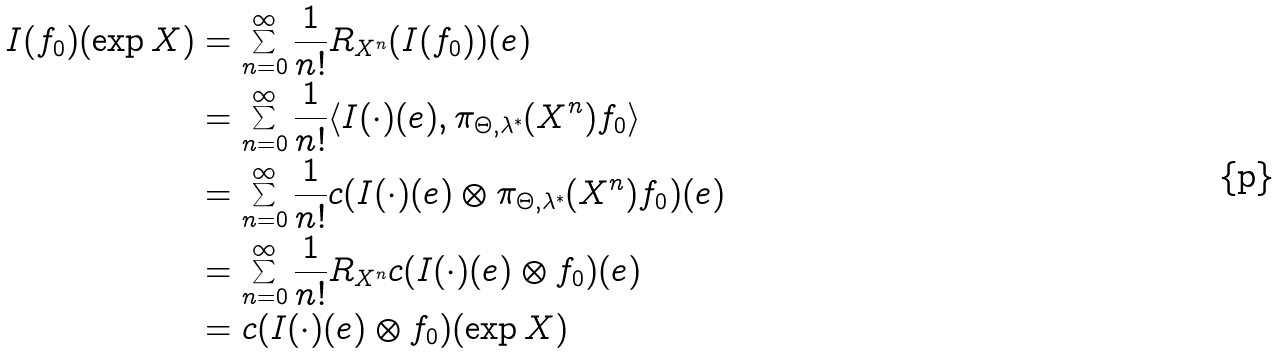<formula> <loc_0><loc_0><loc_500><loc_500>I ( f _ { 0 } ) ( \exp X ) & = \sum _ { n = 0 } ^ { \infty } \frac { 1 } { n ! } R _ { X ^ { n } } ( I ( f _ { 0 } ) ) ( e ) \\ & = \sum _ { n = 0 } ^ { \infty } \frac { 1 } { n ! } \langle I ( \cdot ) ( e ) , \pi _ { \Theta , \lambda ^ { * } } ( X ^ { n } ) f _ { 0 } \rangle \\ & = \sum _ { n = 0 } ^ { \infty } \frac { 1 } { n ! } c ( I ( \cdot ) ( e ) \otimes \pi _ { \Theta , \lambda ^ { * } } ( X ^ { n } ) f _ { 0 } ) ( e ) \\ & = \sum _ { n = 0 } ^ { \infty } \frac { 1 } { n ! } R _ { X ^ { n } } c ( I ( \cdot ) ( e ) \otimes f _ { 0 } ) ( e ) \\ & = c ( I ( \cdot ) ( e ) \otimes f _ { 0 } ) ( \exp X )</formula> 